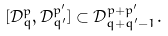<formula> <loc_0><loc_0><loc_500><loc_500>[ \mathcal { D } _ { q } ^ { p } , \mathcal { D } _ { q ^ { \prime } } ^ { p ^ { \prime } } ] \subset \mathcal { D } _ { q + q ^ { \prime } - 1 } ^ { p + p ^ { \prime } } .</formula> 